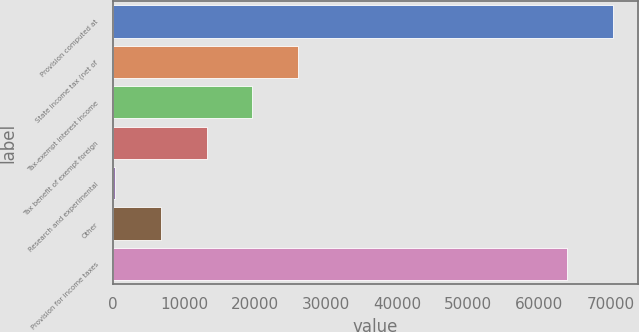Convert chart. <chart><loc_0><loc_0><loc_500><loc_500><bar_chart><fcel>Provision computed at<fcel>State income tax (net of<fcel>Tax-exempt interest income<fcel>Tax benefit of exempt foreign<fcel>Research and experimental<fcel>Other<fcel>Provision for income taxes<nl><fcel>70329.2<fcel>26046.8<fcel>19622.6<fcel>13198.4<fcel>350<fcel>6774.2<fcel>63905<nl></chart> 